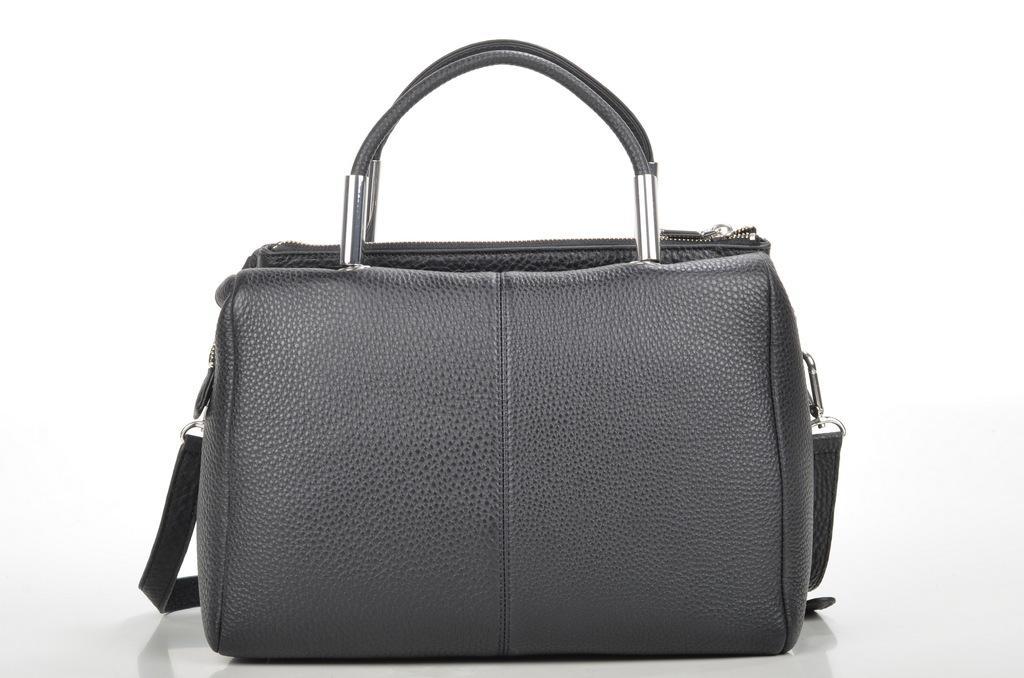How would you summarize this image in a sentence or two? In the image we can see there is a ash colour purse. 